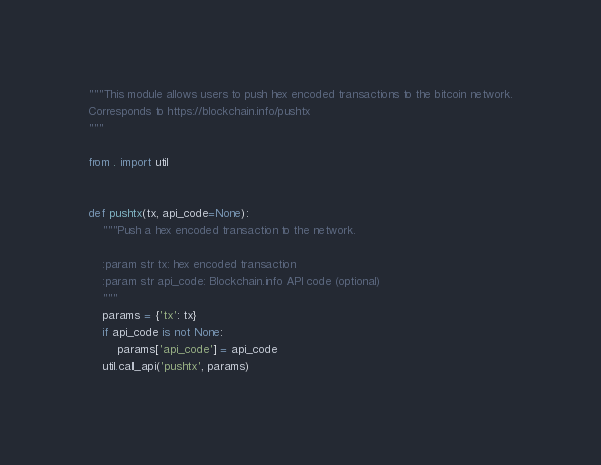Convert code to text. <code><loc_0><loc_0><loc_500><loc_500><_Python_>"""This module allows users to push hex encoded transactions to the bitcoin network.
Corresponds to https://blockchain.info/pushtx
"""

from . import util


def pushtx(tx, api_code=None):
    """Push a hex encoded transaction to the network.
    
    :param str tx: hex encoded transaction
    :param str api_code: Blockchain.info API code (optional)
    """
    params = {'tx': tx}
    if api_code is not None:
        params['api_code'] = api_code
    util.call_api('pushtx', params)
</code> 